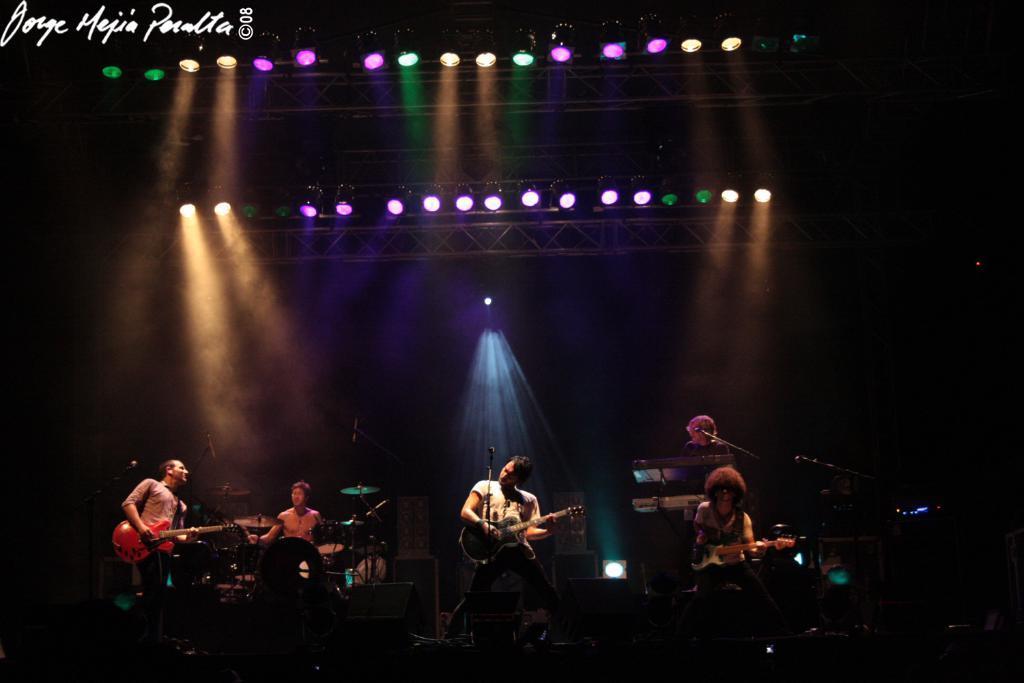Please provide a concise description of this image. In this picture we can see five persons playing musical instruments such as guitar, piano, drums and singing on mic and in background we can see colorful lights with pillar. 